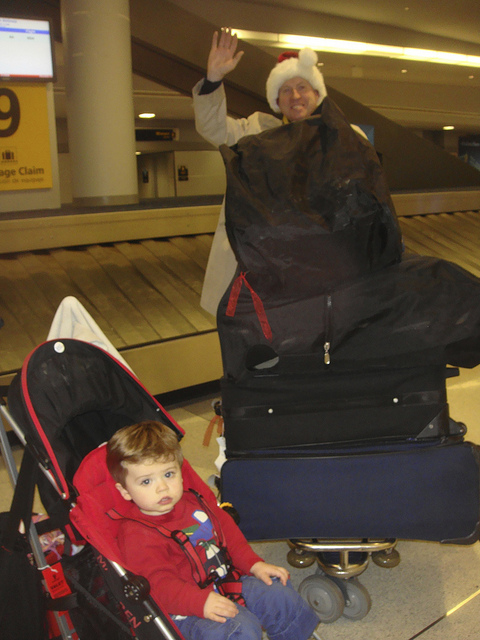Extract all visible text content from this image. 9 